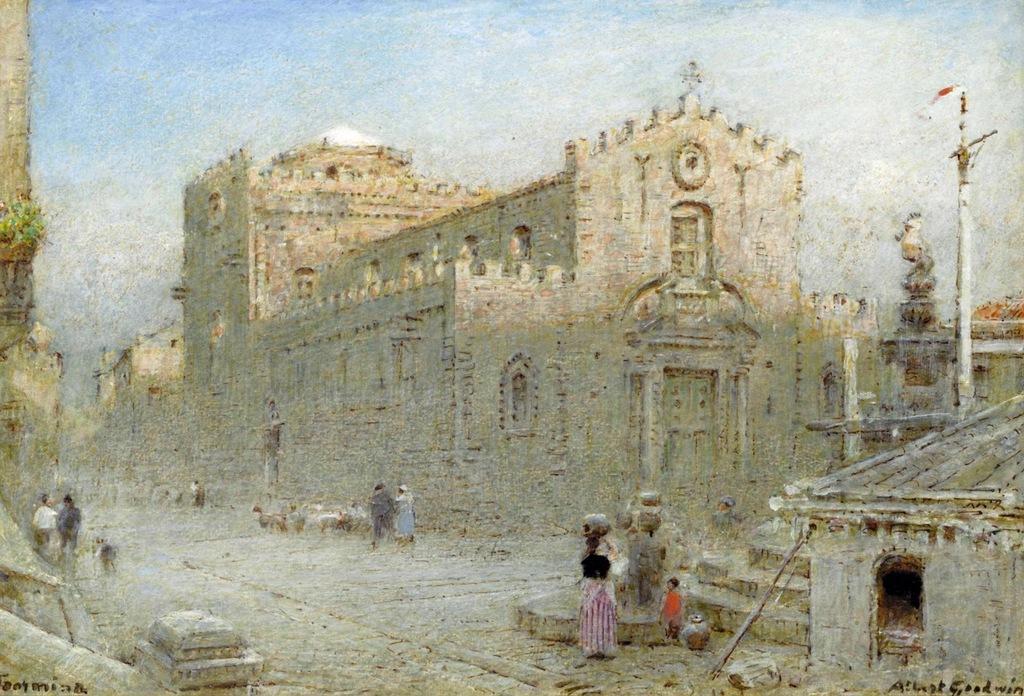Please provide a concise description of this image. In this image we can see a picture of a building. We can also see some people standing on a pathway. On the backside we can see some poles and the sky which looks cloudy. 